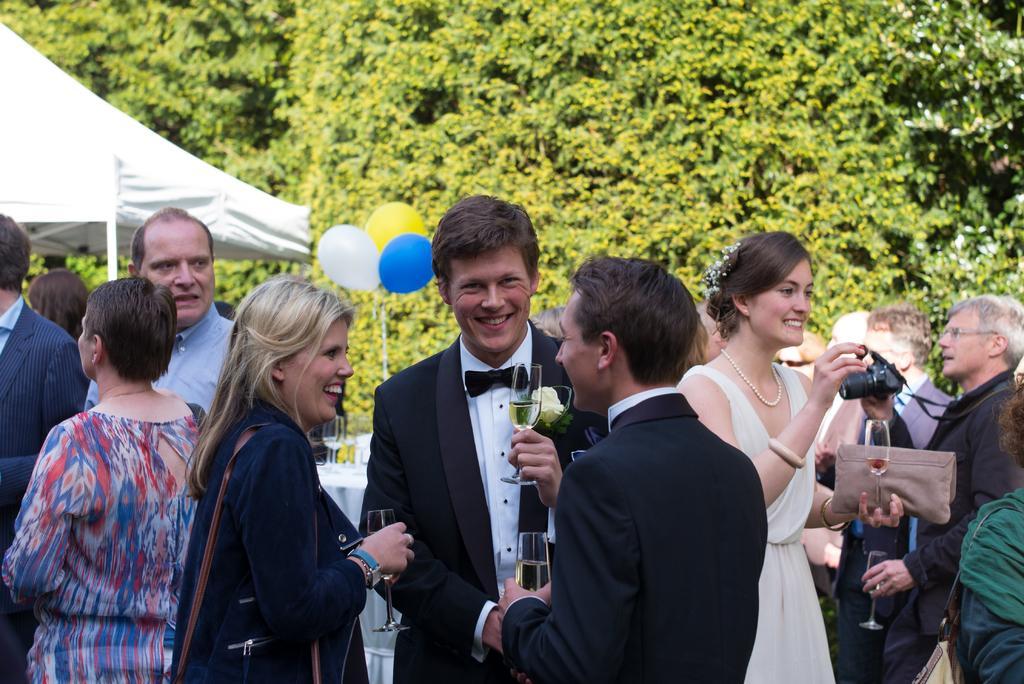Could you give a brief overview of what you see in this image? In this image I can see the group of people with different color dresses and few people with the bags. I can see these people are holding the glasses and one person holding the camera. To the left I can see the tent, balloons and the glasses on the tables. In the background I can see the trees. 